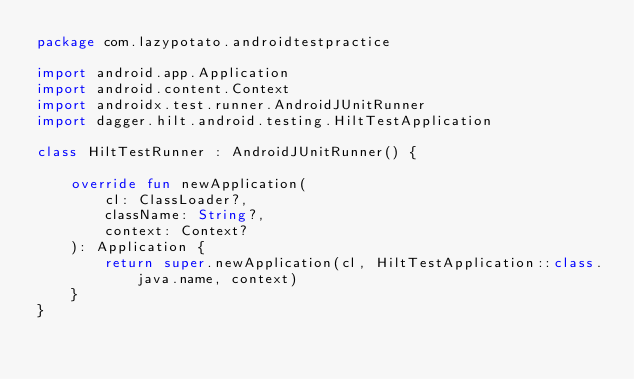Convert code to text. <code><loc_0><loc_0><loc_500><loc_500><_Kotlin_>package com.lazypotato.androidtestpractice

import android.app.Application
import android.content.Context
import androidx.test.runner.AndroidJUnitRunner
import dagger.hilt.android.testing.HiltTestApplication

class HiltTestRunner : AndroidJUnitRunner() {

    override fun newApplication(
        cl: ClassLoader?,
        className: String?,
        context: Context?
    ): Application {
        return super.newApplication(cl, HiltTestApplication::class.java.name, context)
    }
}</code> 